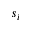<formula> <loc_0><loc_0><loc_500><loc_500>s _ { i }</formula> 